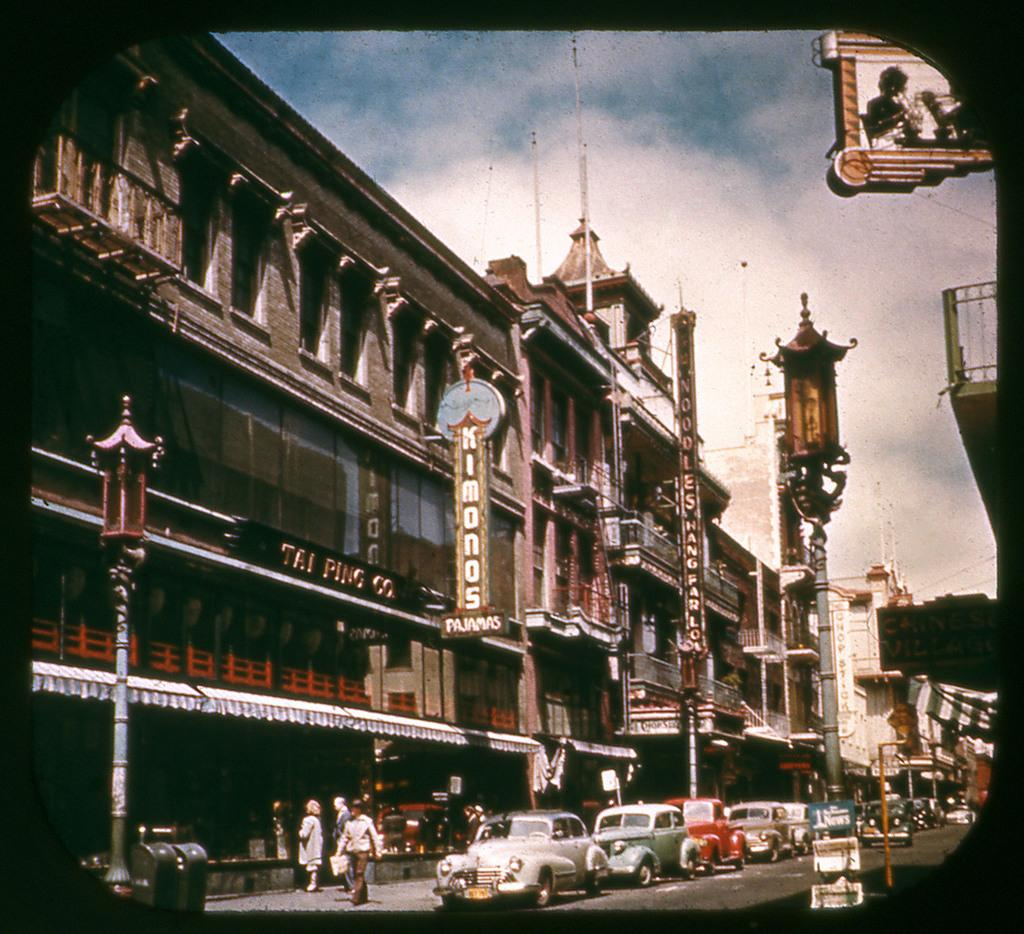<image>
Describe the image concisely. A sign on the side of a building advertises kimonos. 